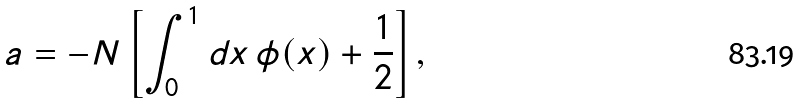<formula> <loc_0><loc_0><loc_500><loc_500>a = - N \left [ \int _ { 0 } ^ { 1 } d x \, \phi ( x ) + \frac { 1 } { 2 } \right ] ,</formula> 